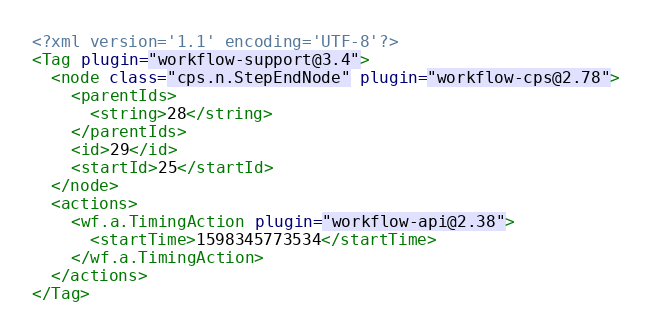<code> <loc_0><loc_0><loc_500><loc_500><_XML_><?xml version='1.1' encoding='UTF-8'?>
<Tag plugin="workflow-support@3.4">
  <node class="cps.n.StepEndNode" plugin="workflow-cps@2.78">
    <parentIds>
      <string>28</string>
    </parentIds>
    <id>29</id>
    <startId>25</startId>
  </node>
  <actions>
    <wf.a.TimingAction plugin="workflow-api@2.38">
      <startTime>1598345773534</startTime>
    </wf.a.TimingAction>
  </actions>
</Tag></code> 